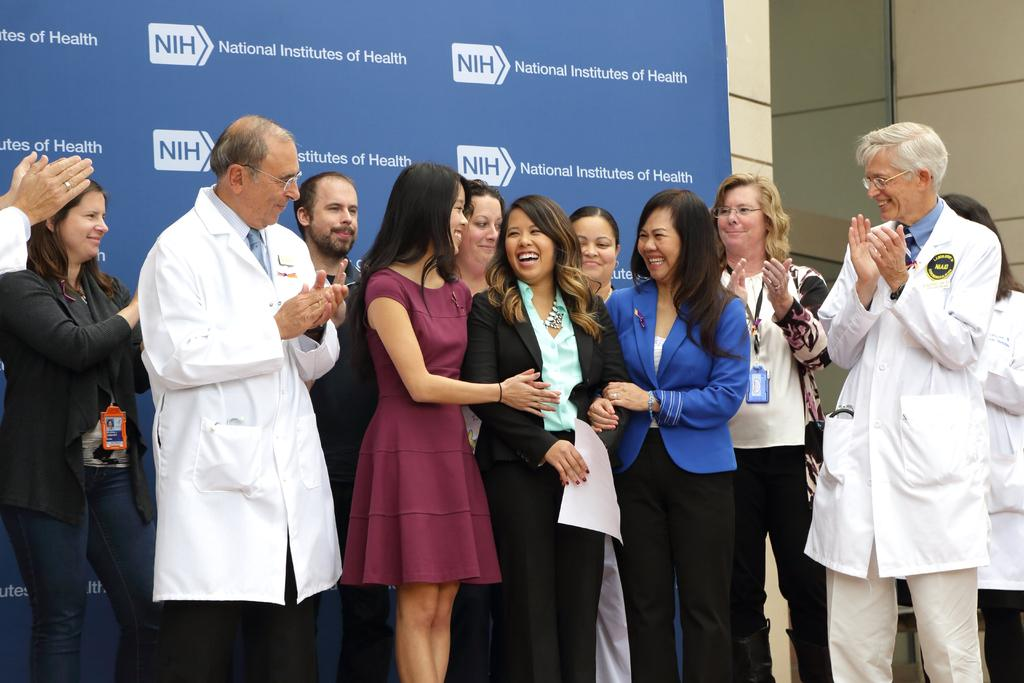What is happening in the image involving a group of people? There is a group of people in the image, and they are standing and smiling. What can be seen behind the group of people? There is a banner behind the group of people. What is visible in the background of the image? There is a wall in the background of the image. What type of pot is being used to generate ideas in the image? There is no pot or idea generation process depicted in the image. What is the cannon's role in the image? There is no cannon present in the image. 